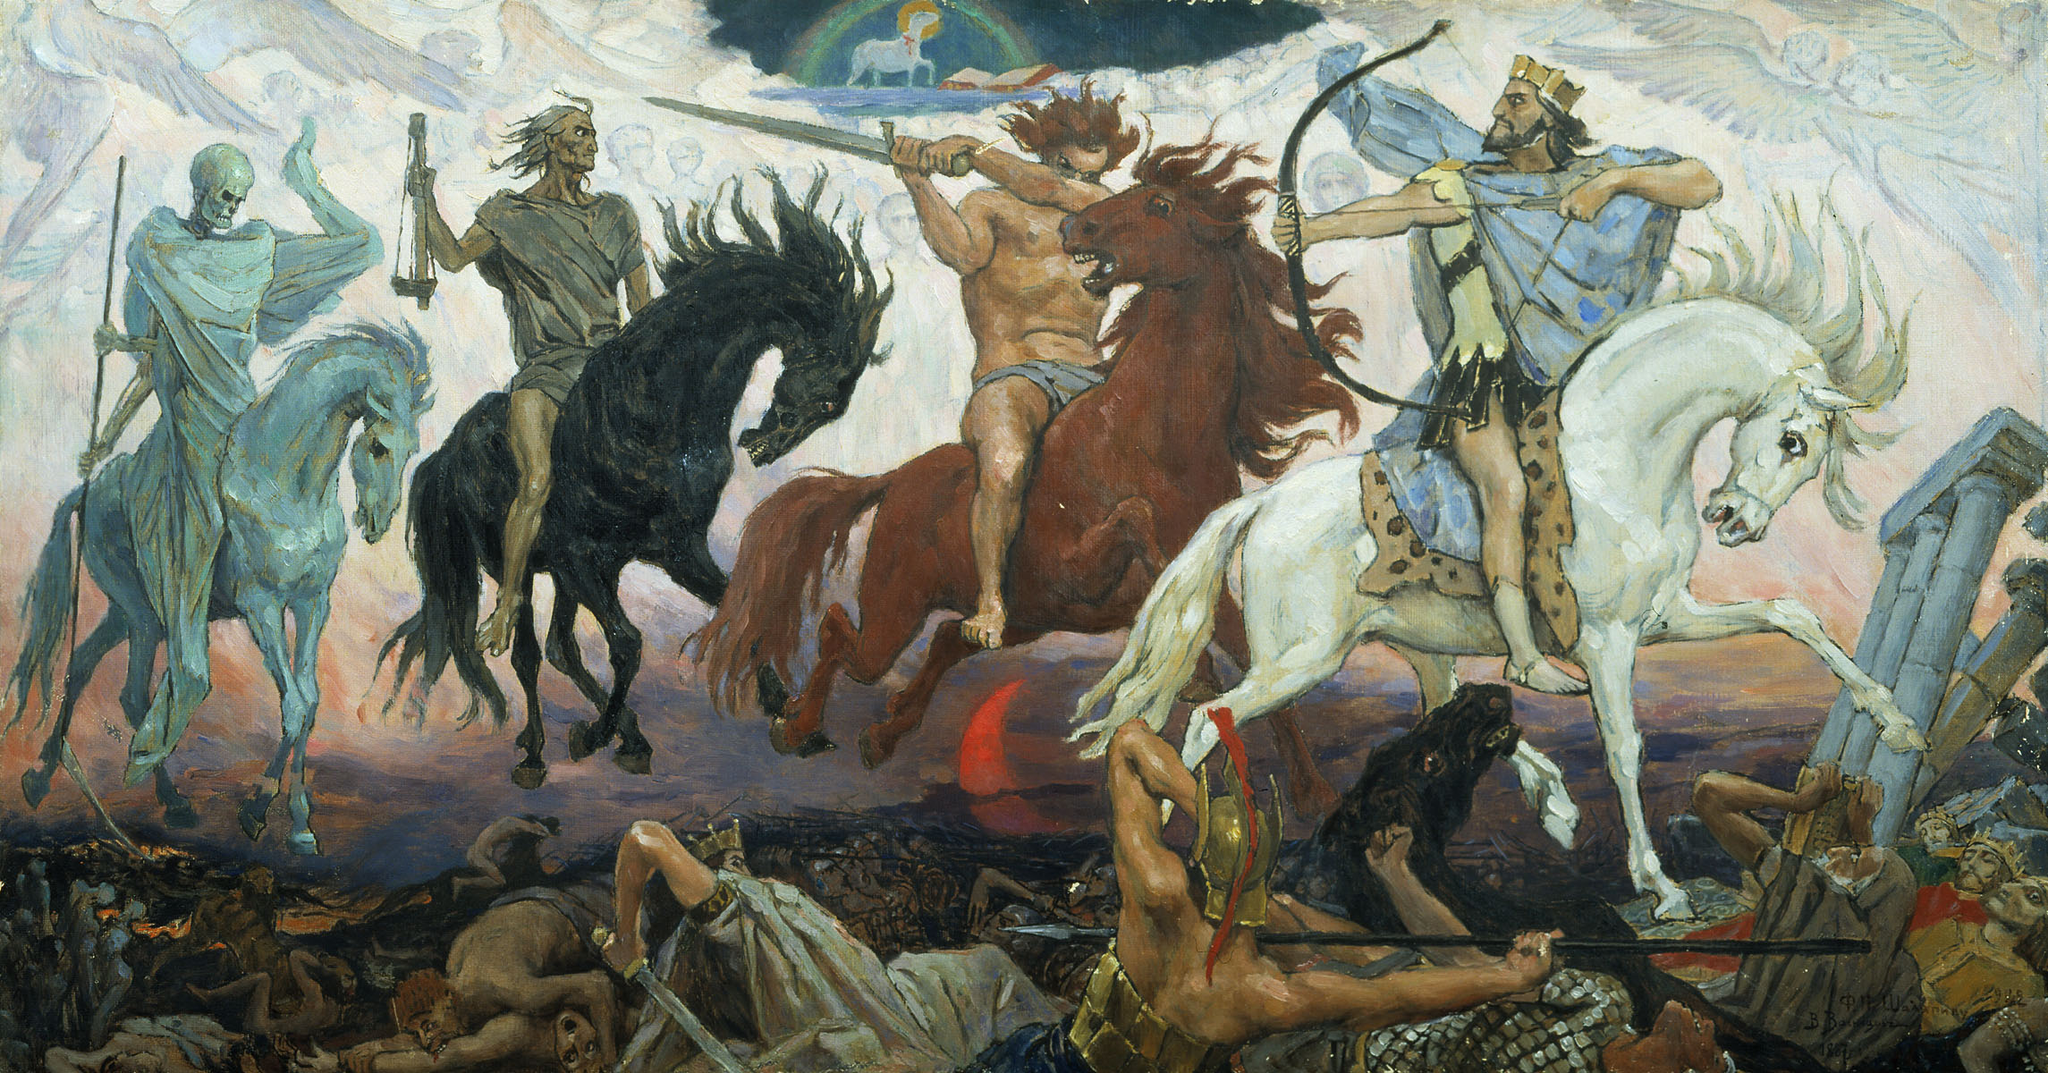Can you identify any potential historical or mythological figures in this artwork? The painting seems to include figures that may be drawn from both history and mythology, creating a rich narrative layer. The skeletal figure on the pale horse strongly resembles depictions of Death, one of the Four Horsemen of the Apocalypse from Christian eschatology, symbolizing the inevitability of death. Other figures, such as the warrior in a classical helmet, might be inspired by historical or mythical warriors, perhaps hinting at a scene from ancient legends or epic literature. 